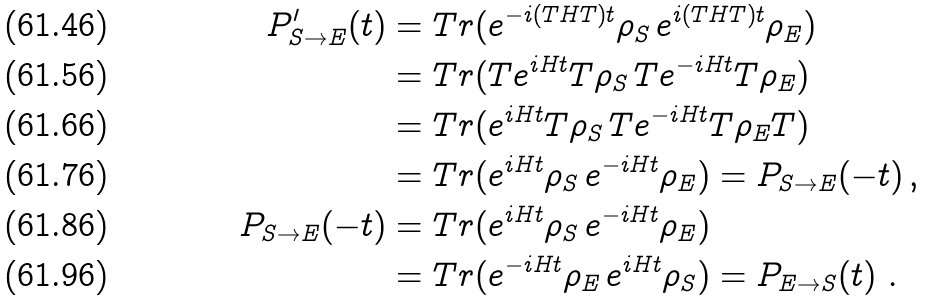Convert formula to latex. <formula><loc_0><loc_0><loc_500><loc_500>P ^ { \prime } _ { S \to E } ( t ) & = T r ( e ^ { - i ( T H T ) t } \rho _ { S } \, e ^ { i ( T H T ) t } \rho _ { E } ) \\ & = T r ( T e ^ { i H t } T \rho _ { S } \, T e ^ { - i H t } T \rho _ { E } ) \\ & = T r ( e ^ { i H t } T \rho _ { S } \, T e ^ { - i H t } T \rho _ { E } T ) \\ & = T r ( e ^ { i H t } \rho _ { S } \, e ^ { - i H t } \rho _ { E } ) = P _ { S \to E } ( - t ) \, , \\ P _ { S \to E } ( - t ) & = T r ( e ^ { i H t } \rho _ { S } \, e ^ { - i H t } \rho _ { E } ) \\ & = T r ( e ^ { - i H t } \rho _ { E } \, e ^ { i H t } \rho _ { S } ) = P _ { E \to S } ( t ) \ .</formula> 